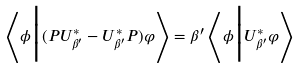Convert formula to latex. <formula><loc_0><loc_0><loc_500><loc_500>\left < \phi \Big { | } ( P U _ { \beta ^ { \prime } } ^ { \ast } - U _ { \beta ^ { \prime } } ^ { \ast } P ) \varphi \right > = \beta ^ { \prime } \left < \phi \Big { | } U _ { \beta ^ { \prime } } ^ { \ast } \varphi \right ></formula> 